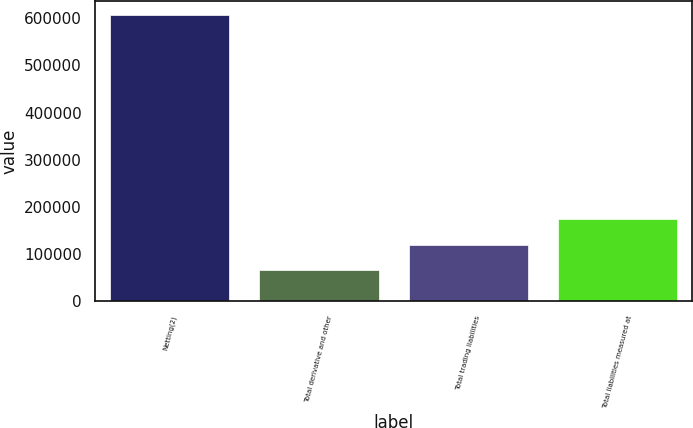Convert chart. <chart><loc_0><loc_0><loc_500><loc_500><bar_chart><fcel>Netting(2)<fcel>Total derivative and other<fcel>Total trading liabilities<fcel>Total liabilities measured at<nl><fcel>606878<fcel>66348<fcel>120401<fcel>174454<nl></chart> 